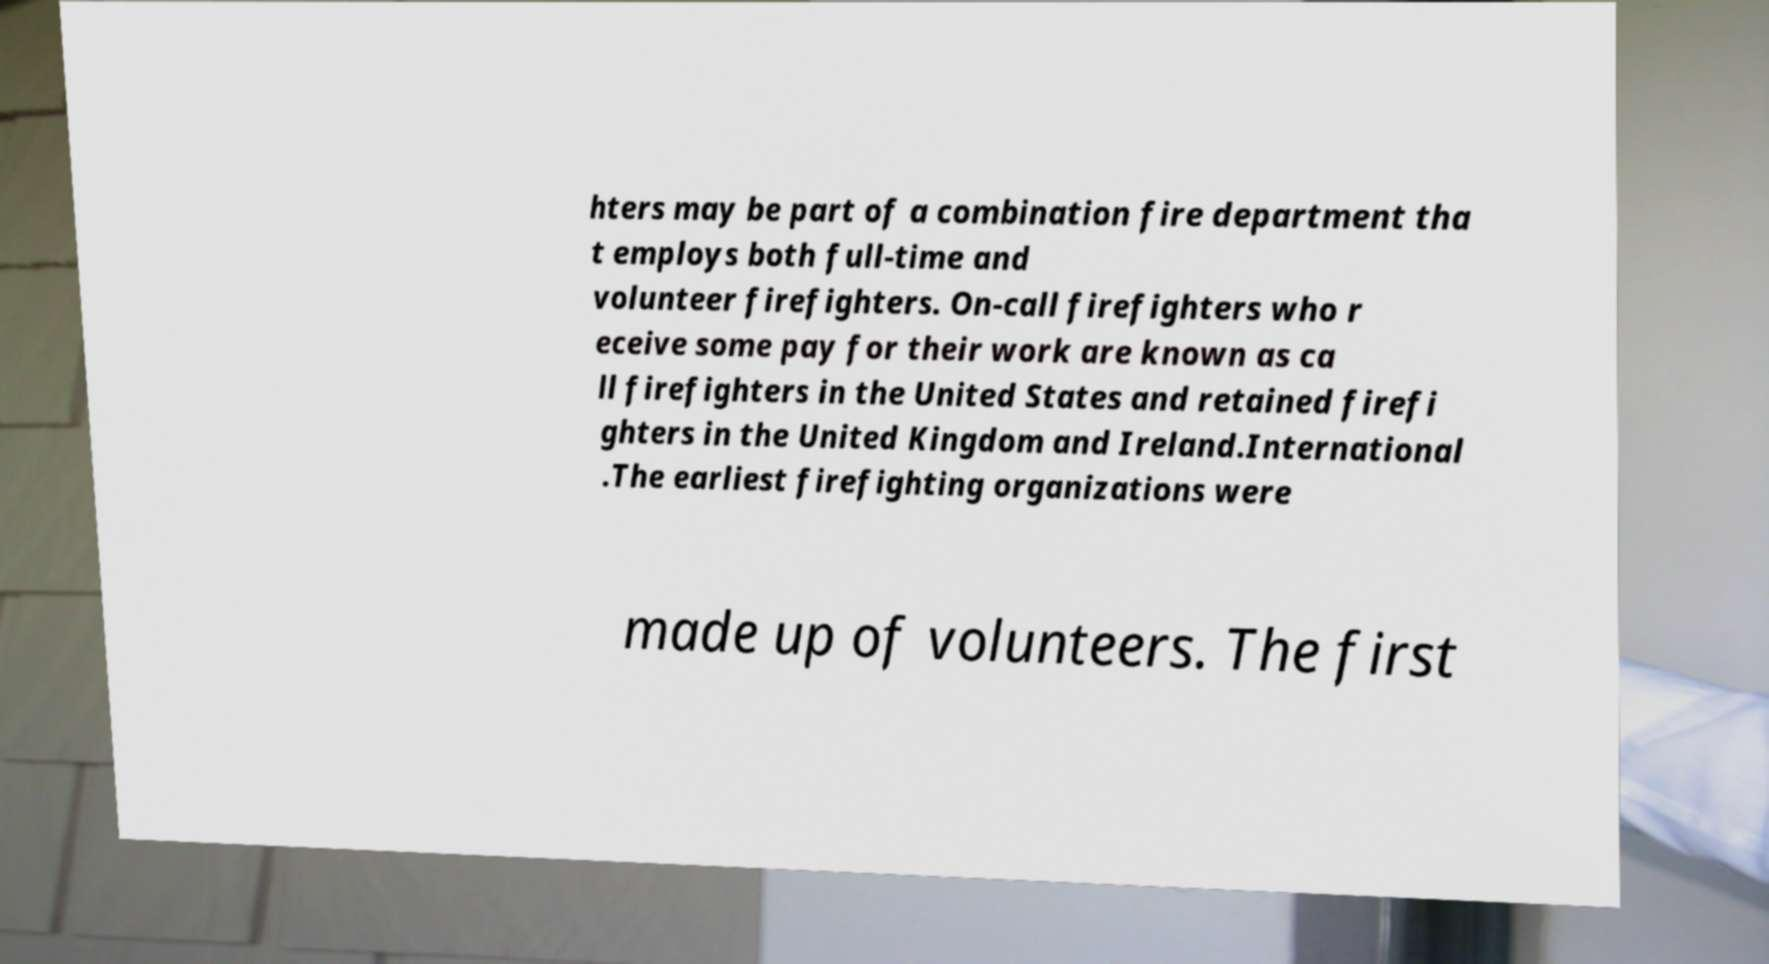Could you assist in decoding the text presented in this image and type it out clearly? hters may be part of a combination fire department tha t employs both full-time and volunteer firefighters. On-call firefighters who r eceive some pay for their work are known as ca ll firefighters in the United States and retained firefi ghters in the United Kingdom and Ireland.International .The earliest firefighting organizations were made up of volunteers. The first 